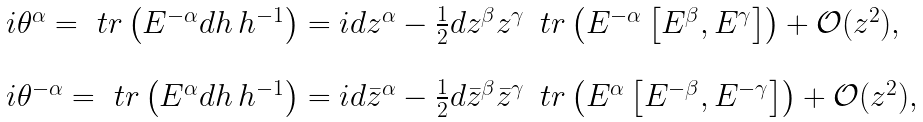<formula> <loc_0><loc_0><loc_500><loc_500>\begin{array} { l } i \theta ^ { \alpha } = \ t r \left ( E ^ { - \alpha } d h \, h ^ { - 1 } \right ) = i d z ^ { \alpha } - \frac { 1 } { 2 } d z ^ { \beta } z ^ { \gamma } \, \ t r \left ( E ^ { - \alpha } \left [ E ^ { \beta } , E ^ { \gamma } \right ] \right ) + \mathcal { O } ( z ^ { 2 } ) , \\ \\ i \theta ^ { - \alpha } = \ t r \left ( E ^ { \alpha } d h \, h ^ { - 1 } \right ) = i d \bar { z } ^ { \alpha } - \frac { 1 } { 2 } d \bar { z } ^ { \beta } \bar { z } ^ { \gamma } \, \ t r \left ( E ^ { \alpha } \left [ E ^ { - \beta } , E ^ { - \gamma } \right ] \right ) + \mathcal { O } ( z ^ { 2 } ) , \end{array}</formula> 